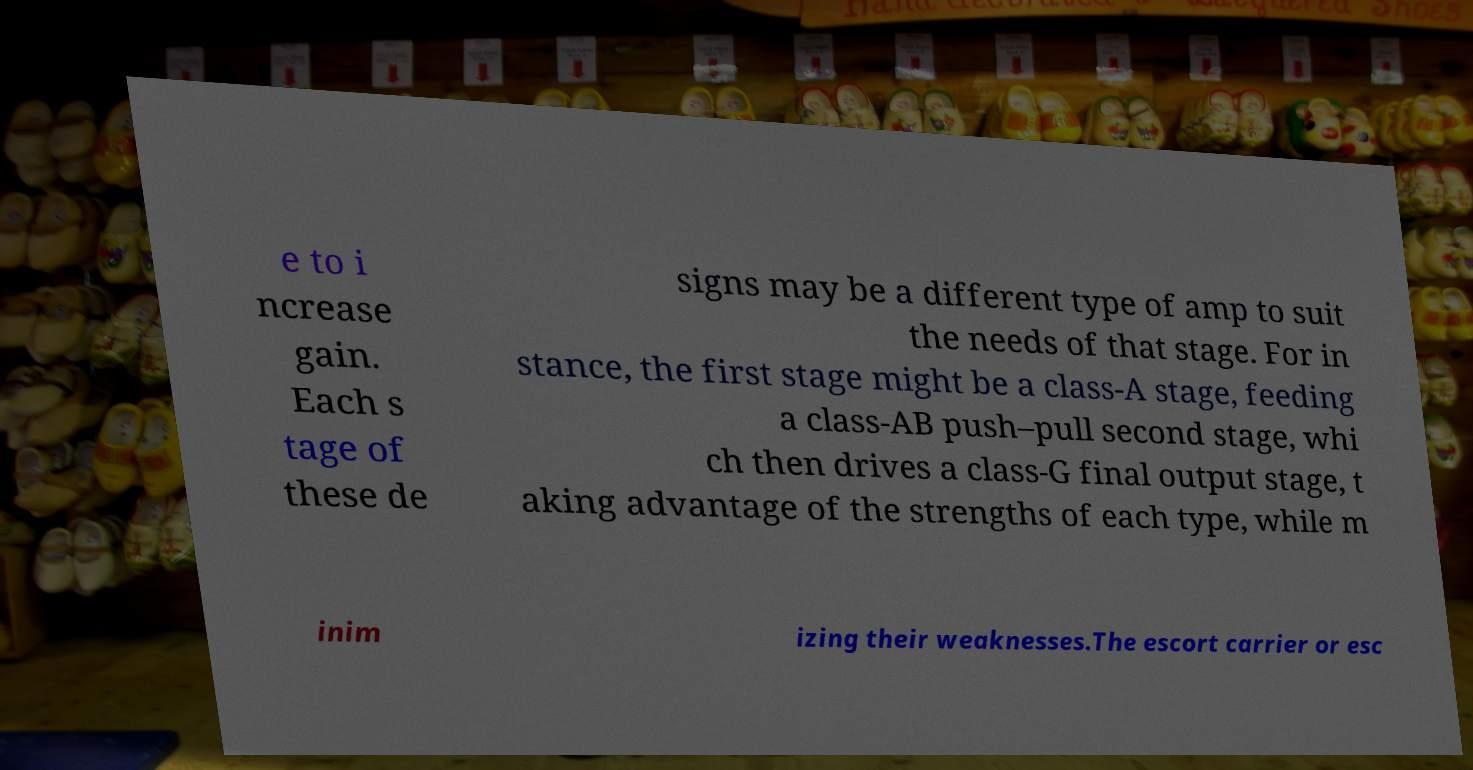Please identify and transcribe the text found in this image. e to i ncrease gain. Each s tage of these de signs may be a different type of amp to suit the needs of that stage. For in stance, the first stage might be a class-A stage, feeding a class-AB push–pull second stage, whi ch then drives a class-G final output stage, t aking advantage of the strengths of each type, while m inim izing their weaknesses.The escort carrier or esc 